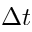<formula> <loc_0><loc_0><loc_500><loc_500>\Delta { t }</formula> 